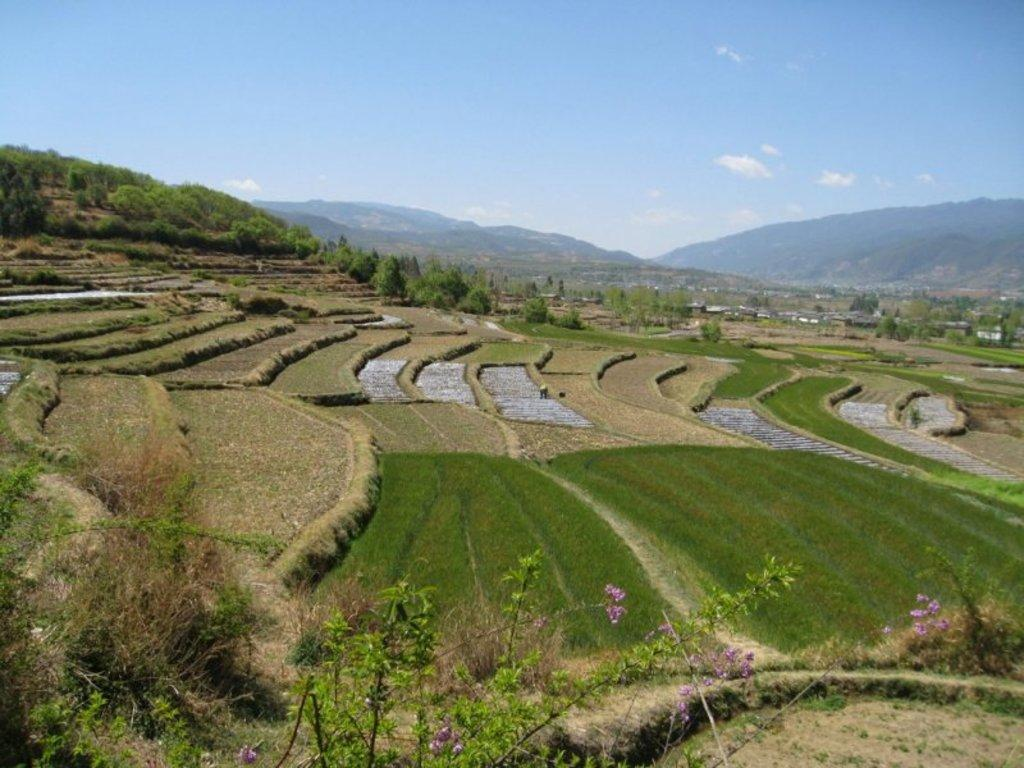What type of vegetation can be seen in the image? There are small plants and dry grass in the image. What other natural elements are visible in the image? Flowers, trees, and mountains are visible in the image. What can be seen in the background of the image? There are houses and trees in the background of the image. What is the color of the sky in the image? The sky is blue and white in color. What statement is being made by the flowers in the image? There is no statement being made by the flowers in the image; they are simply plants. What is the price of the mountains in the image? There is no price associated with the mountains in the image; they are natural landforms. 